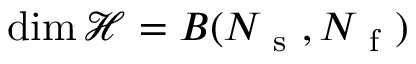Convert formula to latex. <formula><loc_0><loc_0><loc_500><loc_500>\dim \mathcal { H } = B ( N _ { s } , N _ { f } )</formula> 